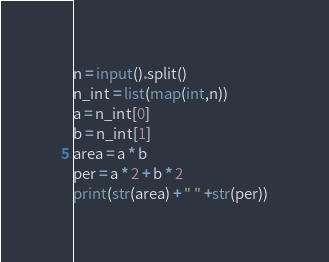<code> <loc_0><loc_0><loc_500><loc_500><_Python_>n = input().split()
n_int = list(map(int,n))
a = n_int[0]
b = n_int[1]
area = a * b
per = a * 2 + b * 2
print(str(area) + " " +str(per))</code> 